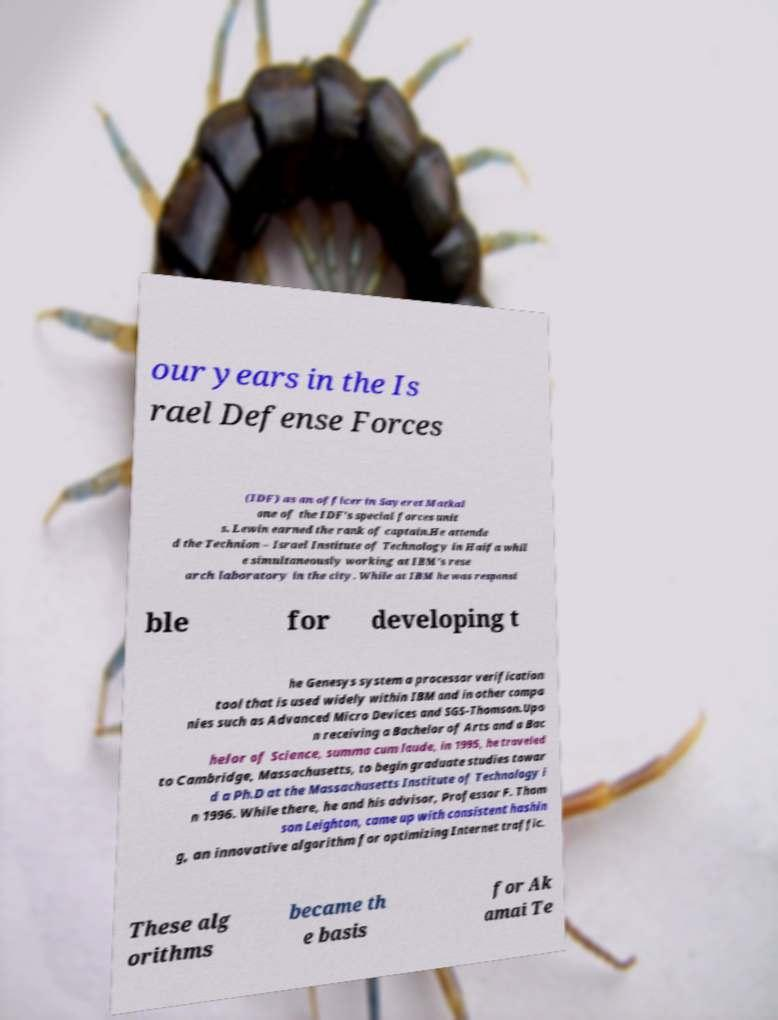For documentation purposes, I need the text within this image transcribed. Could you provide that? our years in the Is rael Defense Forces (IDF) as an officer in Sayeret Matkal one of the IDF's special forces unit s. Lewin earned the rank of captain.He attende d the Technion – Israel Institute of Technology in Haifa whil e simultaneously working at IBM's rese arch laboratory in the city. While at IBM he was responsi ble for developing t he Genesys system a processor verification tool that is used widely within IBM and in other compa nies such as Advanced Micro Devices and SGS-Thomson.Upo n receiving a Bachelor of Arts and a Bac helor of Science, summa cum laude, in 1995, he traveled to Cambridge, Massachusetts, to begin graduate studies towar d a Ph.D at the Massachusetts Institute of Technology i n 1996. While there, he and his advisor, Professor F. Thom son Leighton, came up with consistent hashin g, an innovative algorithm for optimizing Internet traffic. These alg orithms became th e basis for Ak amai Te 